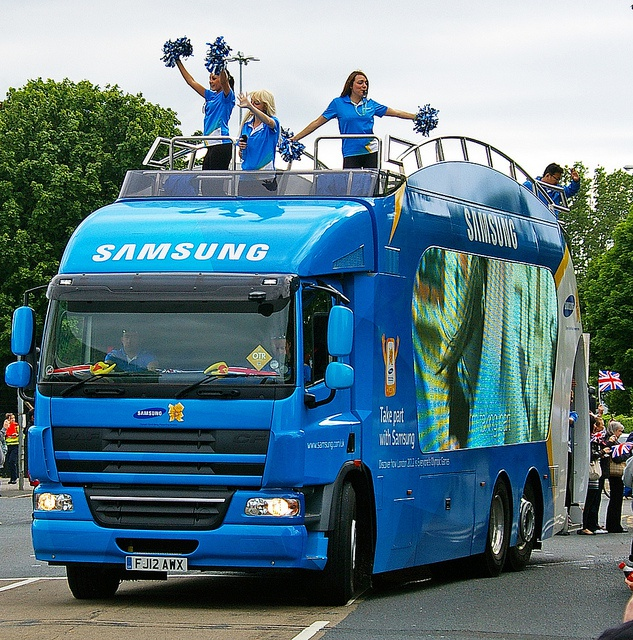Describe the objects in this image and their specific colors. I can see truck in lightgray, black, blue, gray, and navy tones, bus in lightgray, black, blue, gray, and navy tones, people in lightgray, blue, black, and gray tones, people in lightgray, black, white, blue, and darkblue tones, and people in lightgray, blue, white, and darkblue tones in this image. 